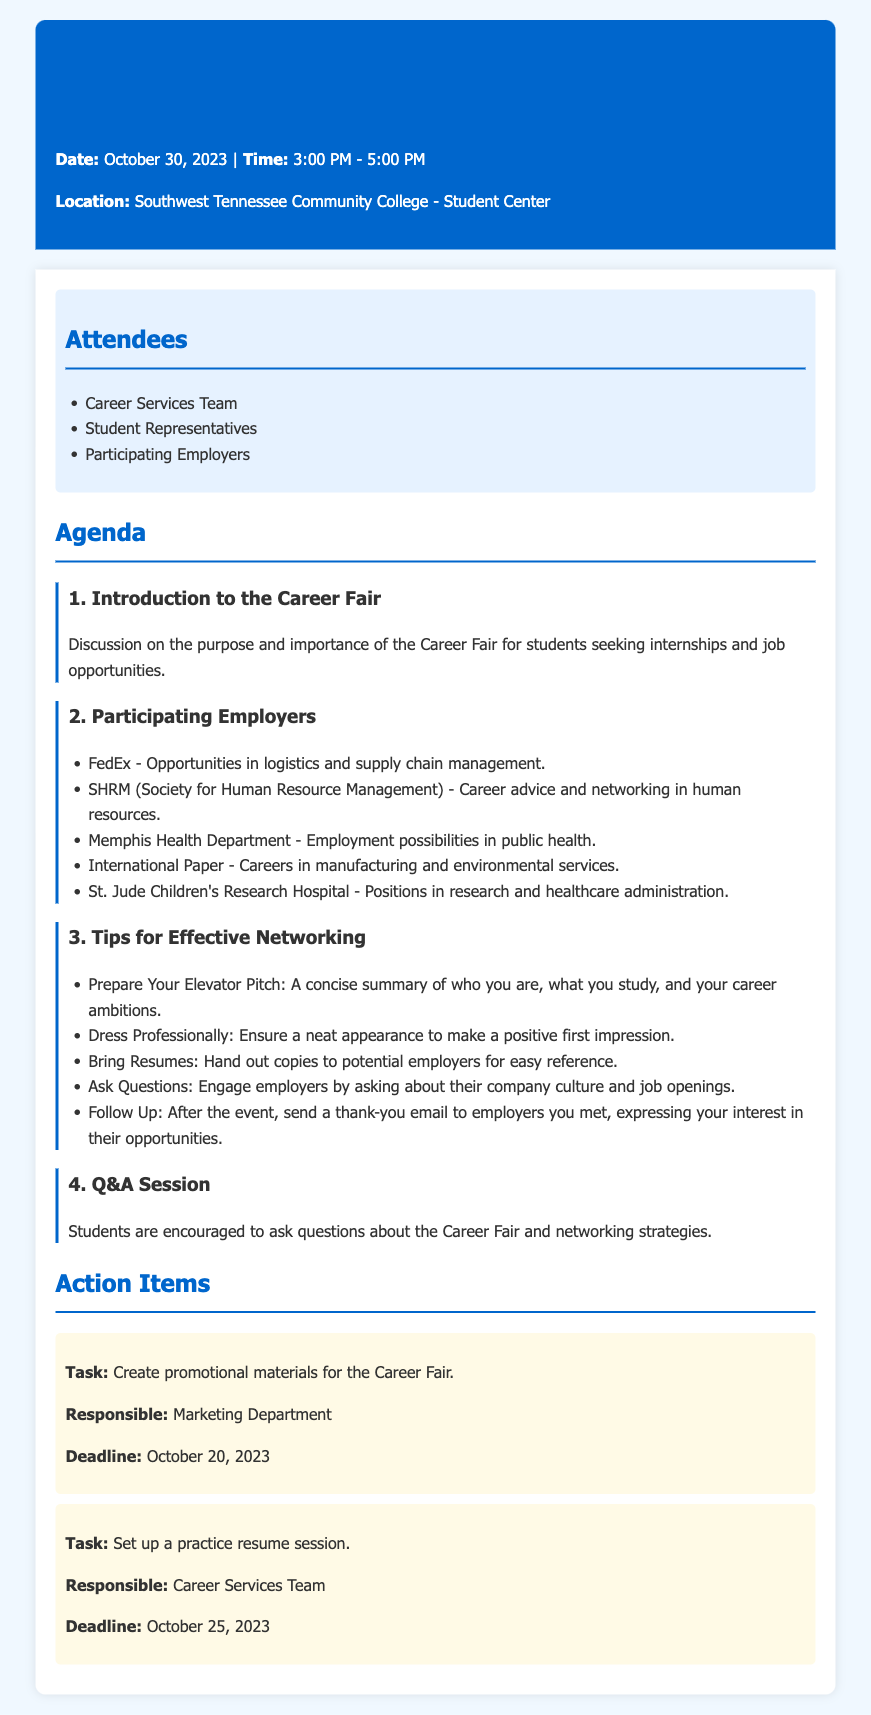What is the date of the Career Fair? The date of the Career Fair is specifically stated in the header of the document.
Answer: October 30, 2023 What time does the Career Fair start? The start time for the Career Fair is mentioned in the header.
Answer: 3:00 PM Which employer offers jobs in public health? The employer associated with public health employment is listed under the participating employers section.
Answer: Memphis Health Department What should you prepare to make a good first impression? The tips for effective networking include specific recommendations about appearance, which are detailed in the document.
Answer: Dress Professionally Who is responsible for creating promotional materials? The responsible entity for the promotional materials task is mentioned under the action items section.
Answer: Marketing Department How many employers are listed as participating? The total number of employers can be counted from the list provided in the document.
Answer: Five What task is due by October 25, 2023? The action item with a specific deadline can be found in the action items section.
Answer: Set up a practice resume session What is suggested to bring to the Career Fair? The document provides specific advice regarding items to carry to the event.
Answer: Bring Resumes What is the purpose of the Career Fair? The document outlines the significance of the event in the introduction section.
Answer: Seeking internships and job opportunities 